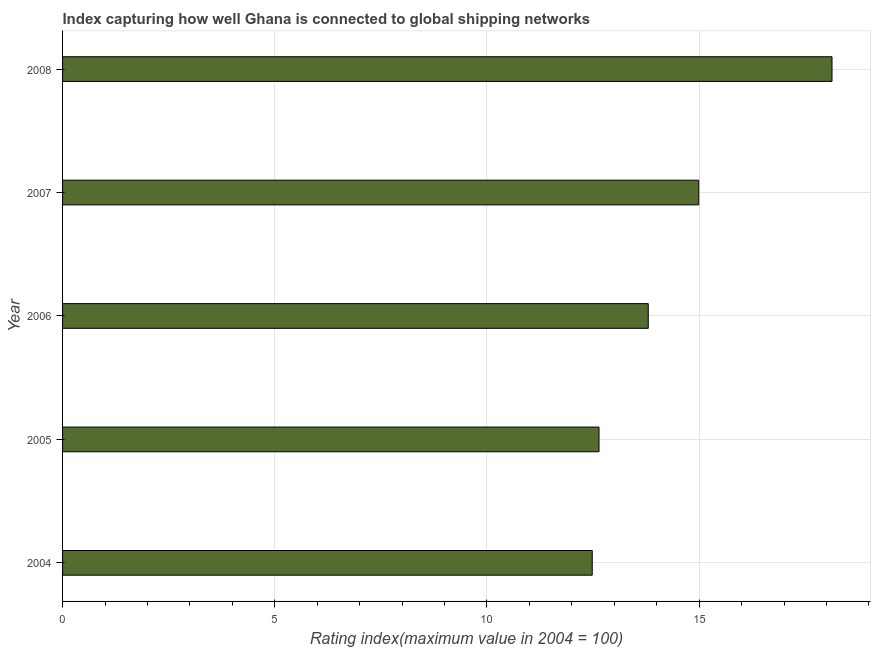Does the graph contain any zero values?
Your answer should be very brief. No. Does the graph contain grids?
Give a very brief answer. Yes. What is the title of the graph?
Give a very brief answer. Index capturing how well Ghana is connected to global shipping networks. What is the label or title of the X-axis?
Ensure brevity in your answer.  Rating index(maximum value in 2004 = 100). What is the label or title of the Y-axis?
Give a very brief answer. Year. What is the liner shipping connectivity index in 2007?
Ensure brevity in your answer.  14.99. Across all years, what is the maximum liner shipping connectivity index?
Provide a succinct answer. 18.13. Across all years, what is the minimum liner shipping connectivity index?
Your answer should be very brief. 12.48. What is the sum of the liner shipping connectivity index?
Keep it short and to the point. 72.04. What is the difference between the liner shipping connectivity index in 2004 and 2005?
Ensure brevity in your answer.  -0.16. What is the average liner shipping connectivity index per year?
Provide a short and direct response. 14.41. What is the median liner shipping connectivity index?
Your response must be concise. 13.8. In how many years, is the liner shipping connectivity index greater than 10 ?
Provide a succinct answer. 5. Do a majority of the years between 2007 and 2004 (inclusive) have liner shipping connectivity index greater than 15 ?
Your response must be concise. Yes. What is the ratio of the liner shipping connectivity index in 2005 to that in 2008?
Offer a terse response. 0.7. Is the liner shipping connectivity index in 2005 less than that in 2008?
Ensure brevity in your answer.  Yes. What is the difference between the highest and the second highest liner shipping connectivity index?
Your response must be concise. 3.14. Is the sum of the liner shipping connectivity index in 2004 and 2006 greater than the maximum liner shipping connectivity index across all years?
Make the answer very short. Yes. What is the difference between the highest and the lowest liner shipping connectivity index?
Provide a succinct answer. 5.65. What is the Rating index(maximum value in 2004 = 100) of 2004?
Offer a very short reply. 12.48. What is the Rating index(maximum value in 2004 = 100) in 2005?
Provide a short and direct response. 12.64. What is the Rating index(maximum value in 2004 = 100) of 2006?
Provide a short and direct response. 13.8. What is the Rating index(maximum value in 2004 = 100) in 2007?
Make the answer very short. 14.99. What is the Rating index(maximum value in 2004 = 100) in 2008?
Provide a succinct answer. 18.13. What is the difference between the Rating index(maximum value in 2004 = 100) in 2004 and 2005?
Keep it short and to the point. -0.16. What is the difference between the Rating index(maximum value in 2004 = 100) in 2004 and 2006?
Your answer should be compact. -1.32. What is the difference between the Rating index(maximum value in 2004 = 100) in 2004 and 2007?
Your answer should be very brief. -2.51. What is the difference between the Rating index(maximum value in 2004 = 100) in 2004 and 2008?
Provide a succinct answer. -5.65. What is the difference between the Rating index(maximum value in 2004 = 100) in 2005 and 2006?
Your response must be concise. -1.16. What is the difference between the Rating index(maximum value in 2004 = 100) in 2005 and 2007?
Offer a very short reply. -2.35. What is the difference between the Rating index(maximum value in 2004 = 100) in 2005 and 2008?
Your answer should be compact. -5.49. What is the difference between the Rating index(maximum value in 2004 = 100) in 2006 and 2007?
Offer a terse response. -1.19. What is the difference between the Rating index(maximum value in 2004 = 100) in 2006 and 2008?
Provide a short and direct response. -4.33. What is the difference between the Rating index(maximum value in 2004 = 100) in 2007 and 2008?
Your response must be concise. -3.14. What is the ratio of the Rating index(maximum value in 2004 = 100) in 2004 to that in 2005?
Your response must be concise. 0.99. What is the ratio of the Rating index(maximum value in 2004 = 100) in 2004 to that in 2006?
Keep it short and to the point. 0.9. What is the ratio of the Rating index(maximum value in 2004 = 100) in 2004 to that in 2007?
Offer a very short reply. 0.83. What is the ratio of the Rating index(maximum value in 2004 = 100) in 2004 to that in 2008?
Provide a short and direct response. 0.69. What is the ratio of the Rating index(maximum value in 2004 = 100) in 2005 to that in 2006?
Ensure brevity in your answer.  0.92. What is the ratio of the Rating index(maximum value in 2004 = 100) in 2005 to that in 2007?
Your answer should be compact. 0.84. What is the ratio of the Rating index(maximum value in 2004 = 100) in 2005 to that in 2008?
Provide a succinct answer. 0.7. What is the ratio of the Rating index(maximum value in 2004 = 100) in 2006 to that in 2007?
Offer a very short reply. 0.92. What is the ratio of the Rating index(maximum value in 2004 = 100) in 2006 to that in 2008?
Offer a terse response. 0.76. What is the ratio of the Rating index(maximum value in 2004 = 100) in 2007 to that in 2008?
Your answer should be very brief. 0.83. 